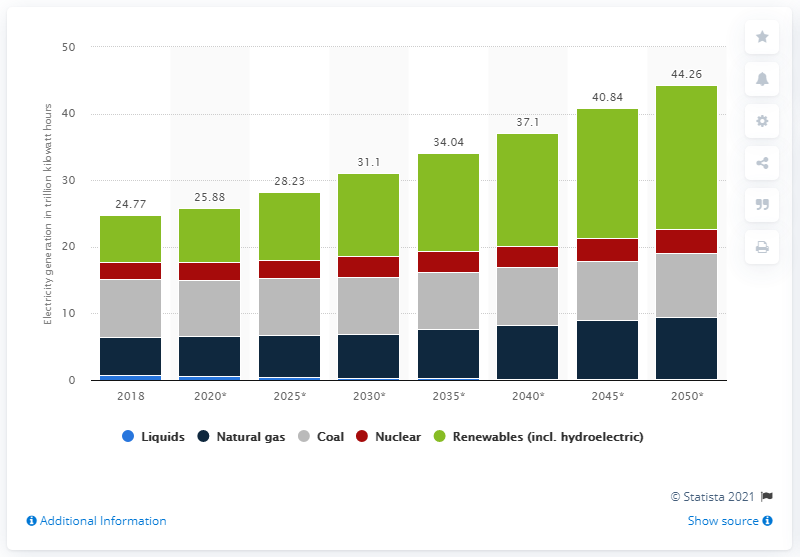Identify some key points in this picture. In 2018, the largest growth in kilowatt hours was 6.99%. By 2050, it is projected that electricity generated from renewable sources will experience significant growth, with an estimated increase of 21.66%. 